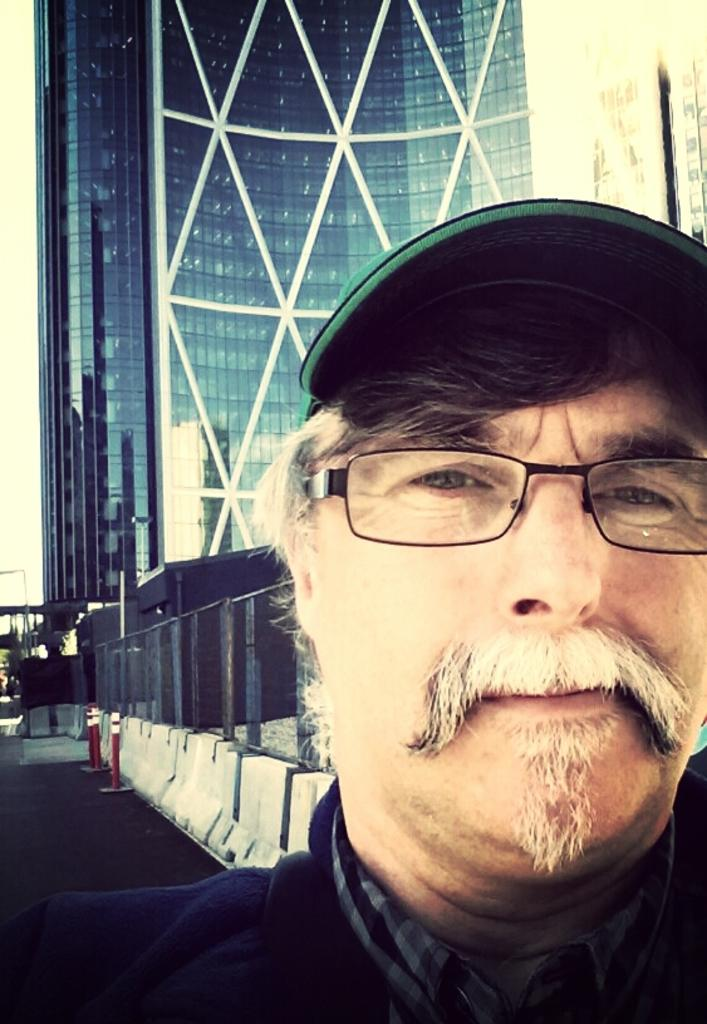Who is present in the image? There is a man in the image. What is the man wearing on his head? The man is wearing a cap. What type of eyewear is the man wearing? The man is wearing spectacles. What can be seen in the background of the image? There is a skyscraper, a metal fence, and other objects visible in the background of the image. What type of nail is the man using to build the building in the image? There is no nail or building construction visible in the image. The man is simply present, wearing a cap and spectacles, with a skyscraper and metal fence in the background. 